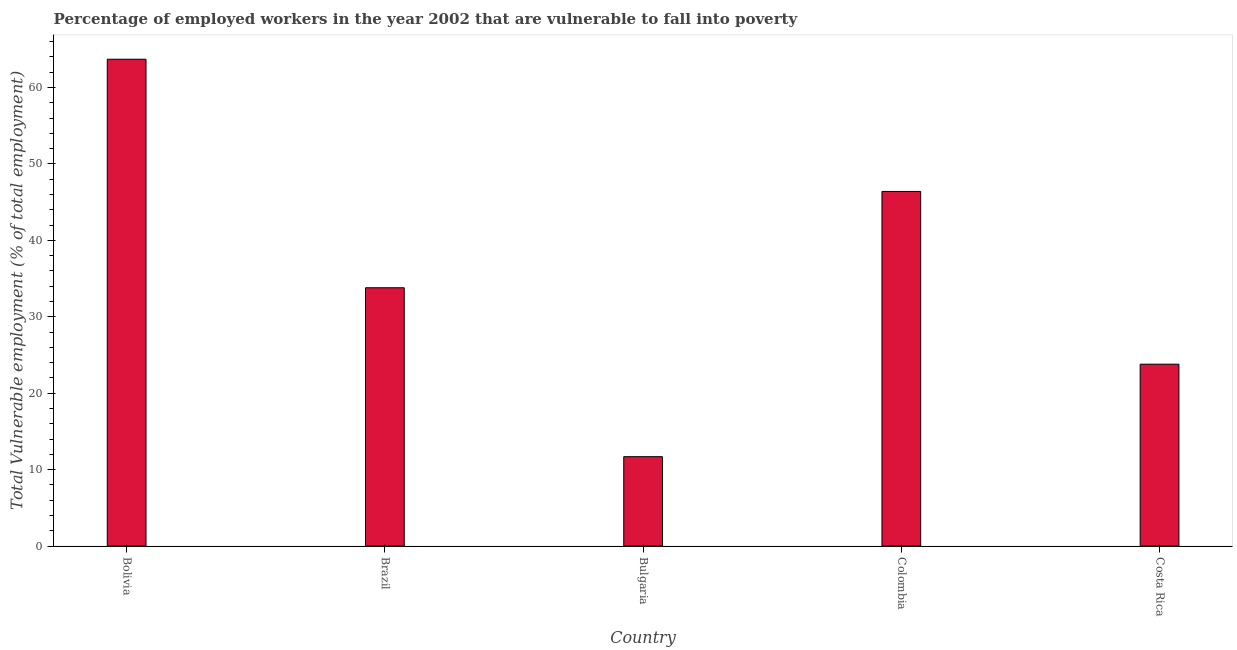Does the graph contain any zero values?
Provide a short and direct response. No. Does the graph contain grids?
Provide a short and direct response. No. What is the title of the graph?
Provide a short and direct response. Percentage of employed workers in the year 2002 that are vulnerable to fall into poverty. What is the label or title of the Y-axis?
Make the answer very short. Total Vulnerable employment (% of total employment). What is the total vulnerable employment in Brazil?
Your answer should be very brief. 33.8. Across all countries, what is the maximum total vulnerable employment?
Offer a very short reply. 63.7. Across all countries, what is the minimum total vulnerable employment?
Offer a terse response. 11.7. In which country was the total vulnerable employment maximum?
Provide a short and direct response. Bolivia. In which country was the total vulnerable employment minimum?
Your answer should be very brief. Bulgaria. What is the sum of the total vulnerable employment?
Provide a succinct answer. 179.4. What is the difference between the total vulnerable employment in Bolivia and Brazil?
Your response must be concise. 29.9. What is the average total vulnerable employment per country?
Provide a short and direct response. 35.88. What is the median total vulnerable employment?
Give a very brief answer. 33.8. In how many countries, is the total vulnerable employment greater than 34 %?
Your answer should be very brief. 2. What is the ratio of the total vulnerable employment in Brazil to that in Bulgaria?
Keep it short and to the point. 2.89. Is the total vulnerable employment in Bolivia less than that in Bulgaria?
Make the answer very short. No. Is the difference between the total vulnerable employment in Brazil and Colombia greater than the difference between any two countries?
Ensure brevity in your answer.  No. What is the difference between the highest and the lowest total vulnerable employment?
Your answer should be compact. 52. In how many countries, is the total vulnerable employment greater than the average total vulnerable employment taken over all countries?
Provide a succinct answer. 2. How many bars are there?
Your response must be concise. 5. How many countries are there in the graph?
Provide a short and direct response. 5. What is the Total Vulnerable employment (% of total employment) in Bolivia?
Make the answer very short. 63.7. What is the Total Vulnerable employment (% of total employment) in Brazil?
Your response must be concise. 33.8. What is the Total Vulnerable employment (% of total employment) in Bulgaria?
Keep it short and to the point. 11.7. What is the Total Vulnerable employment (% of total employment) in Colombia?
Your answer should be very brief. 46.4. What is the Total Vulnerable employment (% of total employment) of Costa Rica?
Give a very brief answer. 23.8. What is the difference between the Total Vulnerable employment (% of total employment) in Bolivia and Brazil?
Provide a short and direct response. 29.9. What is the difference between the Total Vulnerable employment (% of total employment) in Bolivia and Colombia?
Give a very brief answer. 17.3. What is the difference between the Total Vulnerable employment (% of total employment) in Bolivia and Costa Rica?
Make the answer very short. 39.9. What is the difference between the Total Vulnerable employment (% of total employment) in Brazil and Bulgaria?
Make the answer very short. 22.1. What is the difference between the Total Vulnerable employment (% of total employment) in Brazil and Colombia?
Offer a very short reply. -12.6. What is the difference between the Total Vulnerable employment (% of total employment) in Brazil and Costa Rica?
Make the answer very short. 10. What is the difference between the Total Vulnerable employment (% of total employment) in Bulgaria and Colombia?
Give a very brief answer. -34.7. What is the difference between the Total Vulnerable employment (% of total employment) in Colombia and Costa Rica?
Keep it short and to the point. 22.6. What is the ratio of the Total Vulnerable employment (% of total employment) in Bolivia to that in Brazil?
Your response must be concise. 1.89. What is the ratio of the Total Vulnerable employment (% of total employment) in Bolivia to that in Bulgaria?
Offer a terse response. 5.44. What is the ratio of the Total Vulnerable employment (% of total employment) in Bolivia to that in Colombia?
Give a very brief answer. 1.37. What is the ratio of the Total Vulnerable employment (% of total employment) in Bolivia to that in Costa Rica?
Your answer should be very brief. 2.68. What is the ratio of the Total Vulnerable employment (% of total employment) in Brazil to that in Bulgaria?
Provide a succinct answer. 2.89. What is the ratio of the Total Vulnerable employment (% of total employment) in Brazil to that in Colombia?
Provide a short and direct response. 0.73. What is the ratio of the Total Vulnerable employment (% of total employment) in Brazil to that in Costa Rica?
Provide a short and direct response. 1.42. What is the ratio of the Total Vulnerable employment (% of total employment) in Bulgaria to that in Colombia?
Provide a short and direct response. 0.25. What is the ratio of the Total Vulnerable employment (% of total employment) in Bulgaria to that in Costa Rica?
Provide a short and direct response. 0.49. What is the ratio of the Total Vulnerable employment (% of total employment) in Colombia to that in Costa Rica?
Your answer should be very brief. 1.95. 